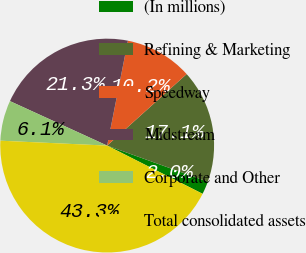<chart> <loc_0><loc_0><loc_500><loc_500><pie_chart><fcel>(In millions)<fcel>Refining & Marketing<fcel>Speedway<fcel>Midstream<fcel>Corporate and Other<fcel>Total consolidated assets<nl><fcel>1.96%<fcel>17.15%<fcel>10.23%<fcel>21.28%<fcel>6.1%<fcel>43.28%<nl></chart> 